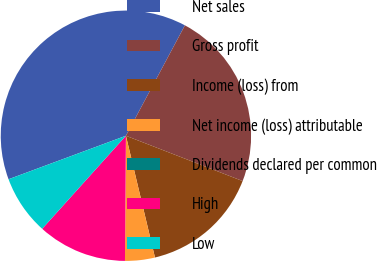<chart> <loc_0><loc_0><loc_500><loc_500><pie_chart><fcel>Net sales<fcel>Gross profit<fcel>Income (loss) from<fcel>Net income (loss) attributable<fcel>Dividends declared per common<fcel>High<fcel>Low<nl><fcel>38.46%<fcel>23.08%<fcel>15.38%<fcel>3.85%<fcel>0.0%<fcel>11.54%<fcel>7.69%<nl></chart> 